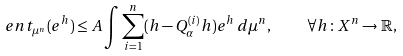<formula> <loc_0><loc_0><loc_500><loc_500>\ e n t _ { \mu ^ { n } } ( e ^ { h } ) \leq A \int \sum _ { i = 1 } ^ { n } ( h - Q _ { \alpha } ^ { ( i ) } h ) e ^ { h } \, d \mu ^ { n } , \quad \forall h \colon X ^ { n } \to \mathbb { R } ,</formula> 